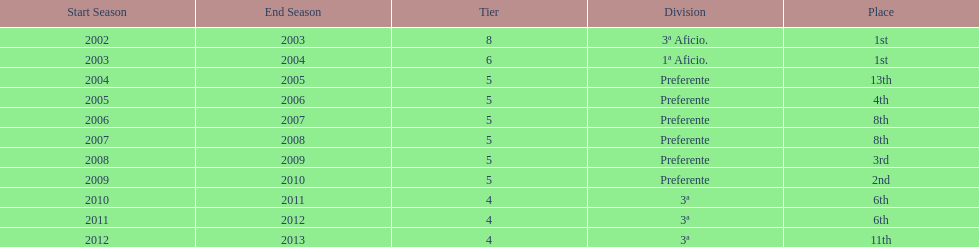In what year did the team achieve the same place as 2010/11? 2011/12. 